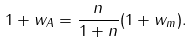Convert formula to latex. <formula><loc_0><loc_0><loc_500><loc_500>1 + w _ { A } = \frac { n } { 1 + n } ( 1 + w _ { m } ) .</formula> 